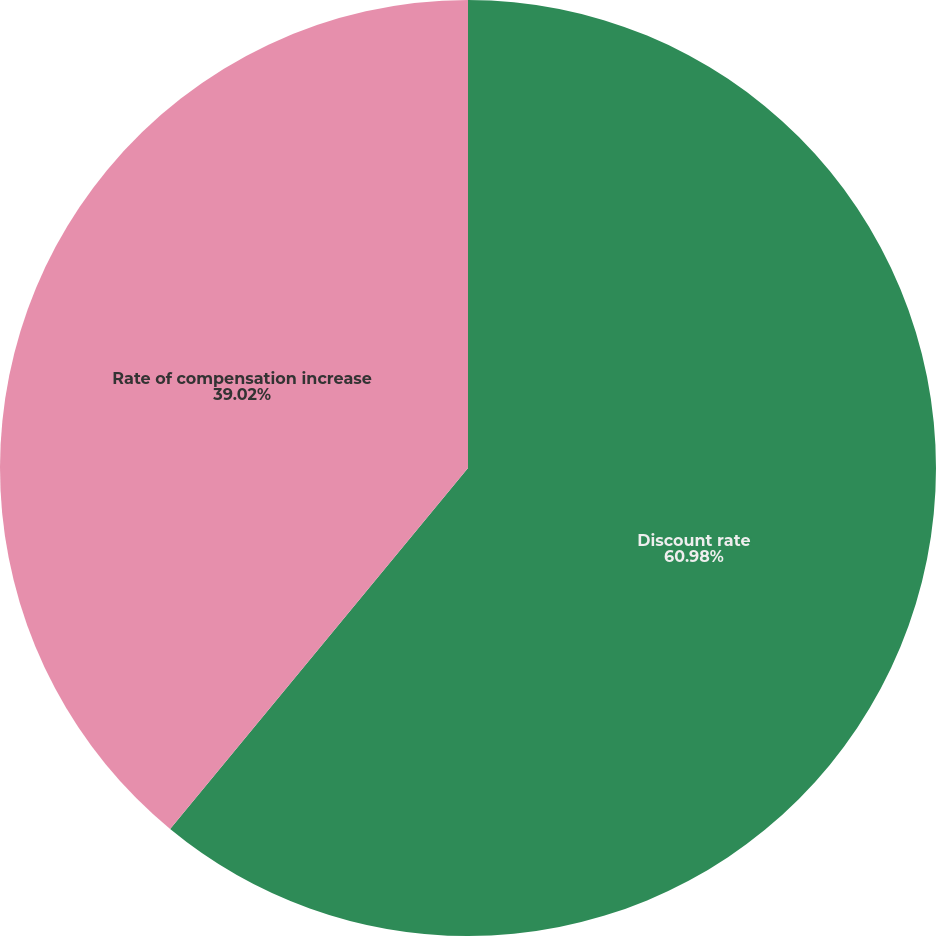Convert chart. <chart><loc_0><loc_0><loc_500><loc_500><pie_chart><fcel>Discount rate<fcel>Rate of compensation increase<nl><fcel>60.98%<fcel>39.02%<nl></chart> 